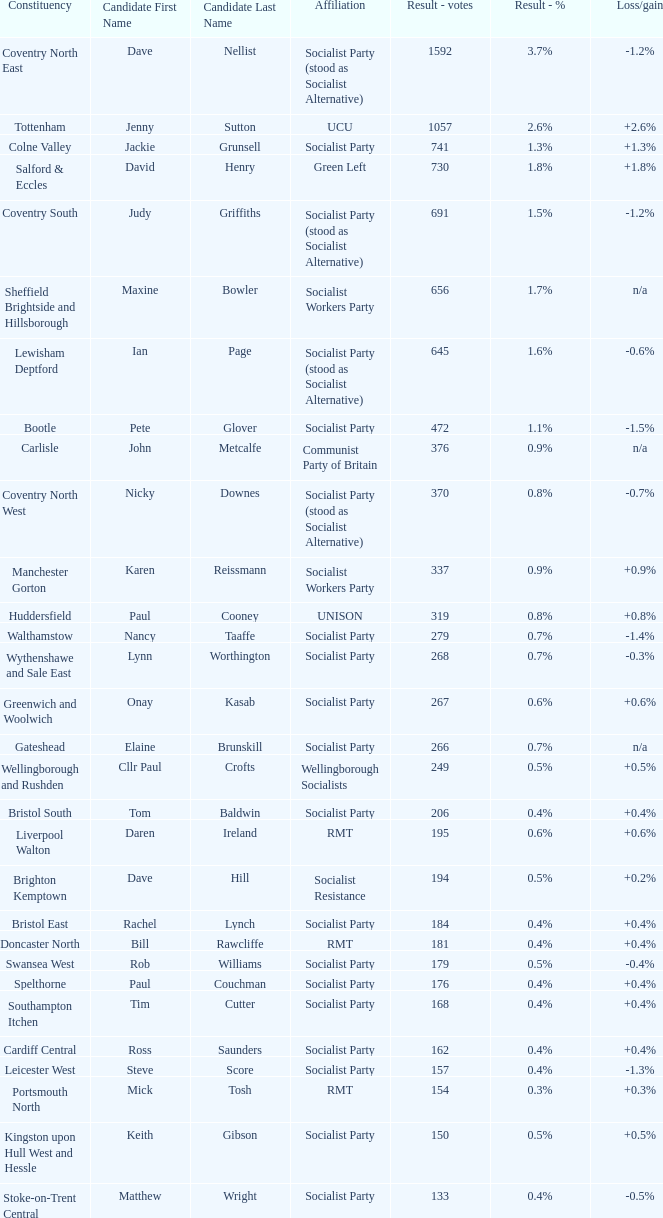What is every affiliation for the Tottenham constituency? UCU. 